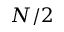<formula> <loc_0><loc_0><loc_500><loc_500>N / 2</formula> 